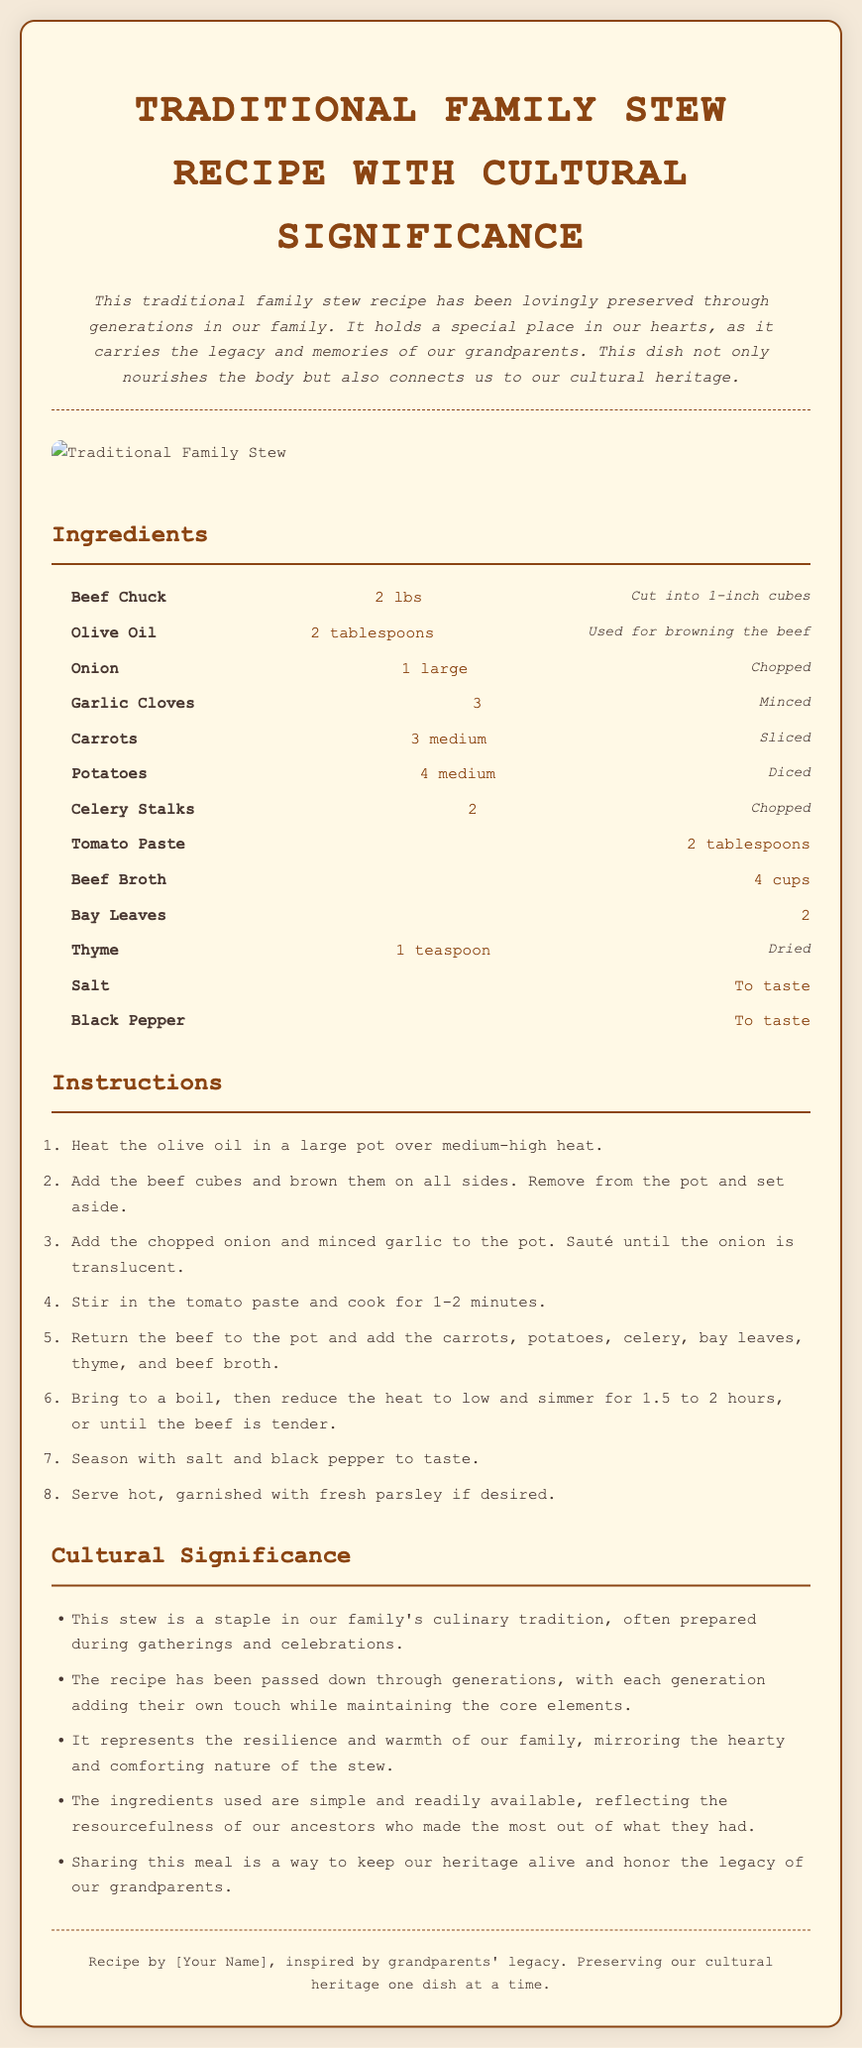What is the main ingredient in the stew? The main ingredient, noted in the ingredients section, is beef chuck.
Answer: Beef Chuck How many cups of beef broth are needed? The recipe specifies the quantity of beef broth in the ingredients list, which is 4 cups.
Answer: 4 cups What is the cooking time for the stew? The instructions indicate the stew should simmer for 1.5 to 2 hours.
Answer: 1.5 to 2 hours What does the stew represent in terms of cultural significance? The cultural significance section states that the stew represents resilience and warmth of the family.
Answer: Resilience and warmth How many cloves of garlic are required for the recipe? The ingredients list specifies that 3 garlic cloves are needed.
Answer: 3 What type of oil is used for browning the beef? The recipe notes that olive oil is used for this purpose.
Answer: Olive Oil What is the significance of sharing the meal? The cultural significance section mentions that sharing this meal honors the legacy of grandparents.
Answer: Honor the legacy How many medium carrots are listed in the ingredients? The ingredients section mentions that 3 medium carrots are required.
Answer: 3 medium What style is the recipe card designed in? The recipe card is presented in a traditional family recipe format with stylistic elements reflecting cultural heritage.
Answer: Traditional family recipe format 